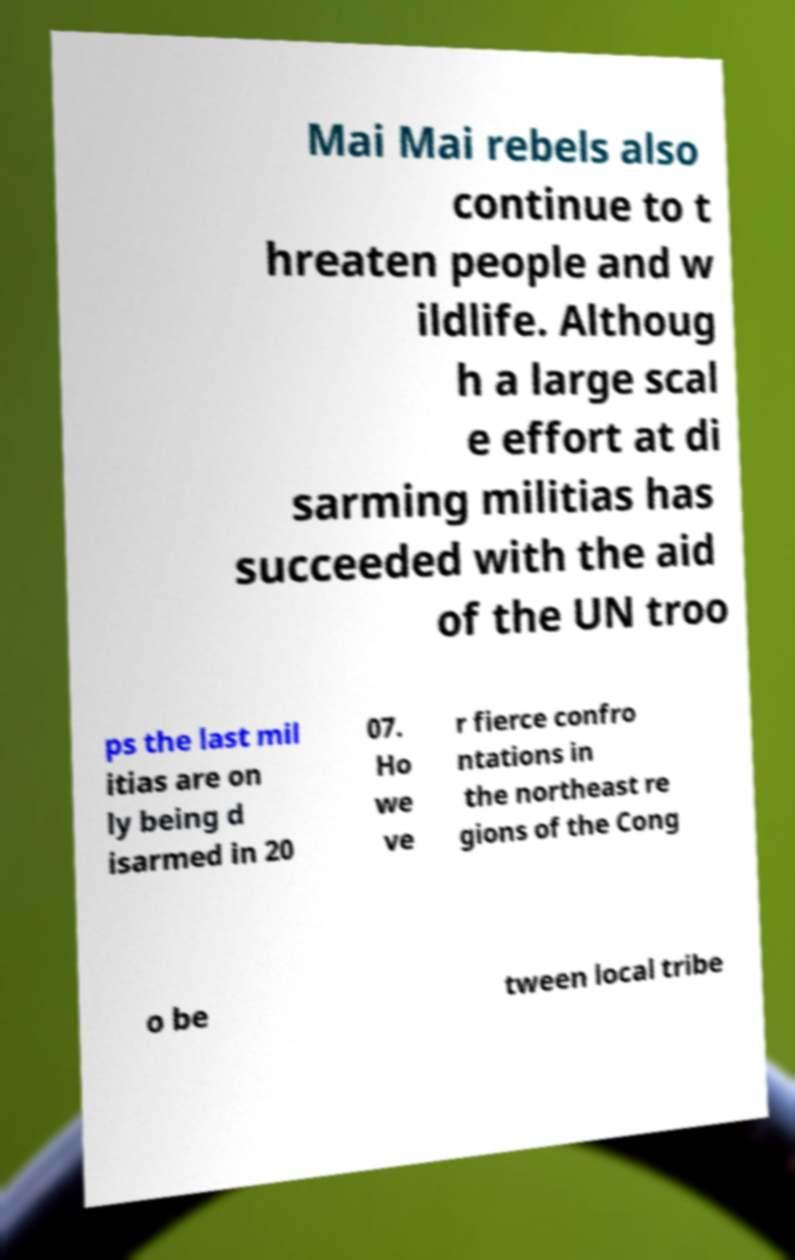Could you assist in decoding the text presented in this image and type it out clearly? Mai Mai rebels also continue to t hreaten people and w ildlife. Althoug h a large scal e effort at di sarming militias has succeeded with the aid of the UN troo ps the last mil itias are on ly being d isarmed in 20 07. Ho we ve r fierce confro ntations in the northeast re gions of the Cong o be tween local tribe 